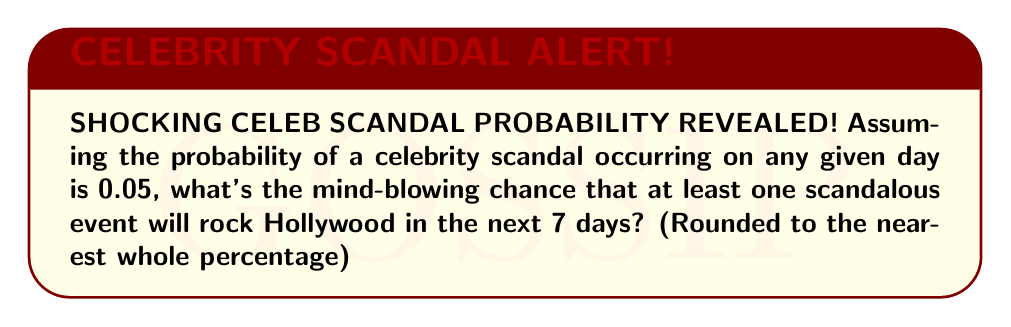Could you help me with this problem? Let's break this down step-by-step:

1) First, let's consider the probability of no scandal occurring on a single day:
   $P(\text{no scandal}) = 1 - 0.05 = 0.95$

2) For no scandal to occur over 7 days, we need this to happen every day:
   $P(\text{no scandal for 7 days}) = 0.95^7$

3) Let's calculate this:
   $0.95^7 \approx 0.6983$

4) Now, the probability of at least one scandal is the opposite of no scandal:
   $P(\text{at least one scandal}) = 1 - P(\text{no scandal for 7 days})$
   $= 1 - 0.6983 \approx 0.3017$

5) Converting to a percentage:
   $0.3017 \times 100\% \approx 30.17\%$

6) Rounding to the nearest whole percentage:
   $30.17\% \approx 30\%$
Answer: 30% 